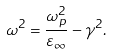Convert formula to latex. <formula><loc_0><loc_0><loc_500><loc_500>\omega ^ { 2 } = \frac { \omega ^ { 2 } _ { p } } { \varepsilon _ { \infty } } - \gamma ^ { 2 } .</formula> 